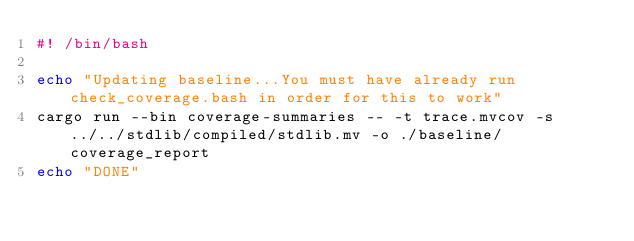Convert code to text. <code><loc_0><loc_0><loc_500><loc_500><_Bash_>#! /bin/bash

echo "Updating baseline...You must have already run check_coverage.bash in order for this to work"
cargo run --bin coverage-summaries -- -t trace.mvcov -s ../../stdlib/compiled/stdlib.mv -o ./baseline/coverage_report
echo "DONE"
</code> 